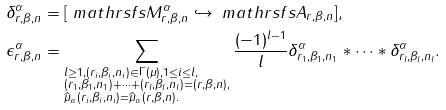Convert formula to latex. <formula><loc_0><loc_0><loc_500><loc_500>\delta _ { r , \beta , n } ^ { \alpha } & = [ \ m a t h r s f s { M } _ { r , \beta , n } ^ { \alpha } \hookrightarrow \ m a t h r s f s { A } _ { r , \beta , n } ] , \\ \epsilon _ { r , \beta , n } ^ { \alpha } & = \sum _ { \begin{subarray} { c } l \geq 1 , ( r _ { i } , \beta _ { i } , n _ { i } ) \in \Gamma ( \mu ) , 1 \leq i \leq l , \\ ( r _ { 1 } , \beta _ { 1 } , n _ { 1 } ) + \cdots + ( r _ { l } , \beta _ { l } , n _ { l } ) = ( r , \beta , n ) , \\ \widehat { \mu } _ { \alpha } ( r _ { i } , \beta _ { i } , n _ { i } ) = \widehat { \mu } _ { \alpha } ( r , \beta , n ) . \end{subarray} } \frac { ( - 1 ) ^ { l - 1 } } { l } \delta _ { r _ { 1 } , \beta _ { 1 } , n _ { 1 } } ^ { \alpha } \ast \cdots \ast \delta _ { r _ { l } , \beta _ { l } , n _ { l } } ^ { \alpha } .</formula> 